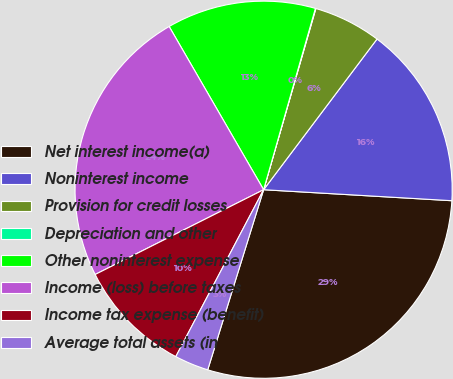Convert chart to OTSL. <chart><loc_0><loc_0><loc_500><loc_500><pie_chart><fcel>Net interest income(a)<fcel>Noninterest income<fcel>Provision for credit losses<fcel>Depreciation and other<fcel>Other noninterest expense<fcel>Income (loss) before taxes<fcel>Income tax expense (benefit)<fcel>Average total assets (in<nl><fcel>28.86%<fcel>15.66%<fcel>5.8%<fcel>0.04%<fcel>12.78%<fcel>24.07%<fcel>9.87%<fcel>2.92%<nl></chart> 